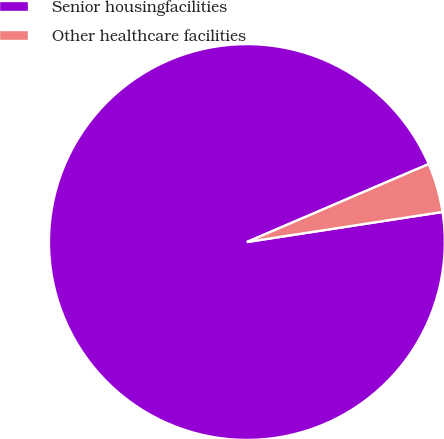<chart> <loc_0><loc_0><loc_500><loc_500><pie_chart><fcel>Senior housingfacilities<fcel>Other healthcare facilities<nl><fcel>95.98%<fcel>4.02%<nl></chart> 